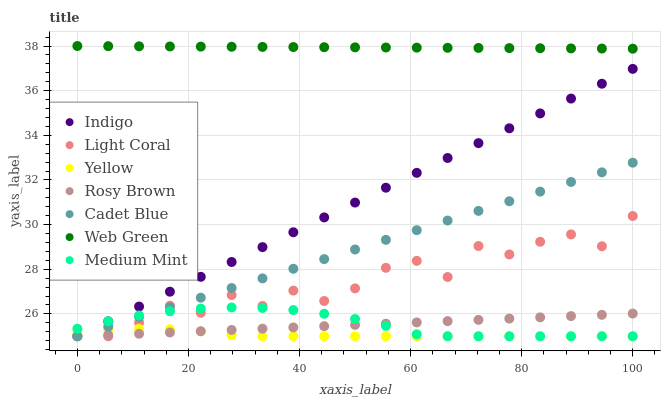Does Yellow have the minimum area under the curve?
Answer yes or no. Yes. Does Web Green have the maximum area under the curve?
Answer yes or no. Yes. Does Cadet Blue have the minimum area under the curve?
Answer yes or no. No. Does Cadet Blue have the maximum area under the curve?
Answer yes or no. No. Is Rosy Brown the smoothest?
Answer yes or no. Yes. Is Light Coral the roughest?
Answer yes or no. Yes. Is Cadet Blue the smoothest?
Answer yes or no. No. Is Cadet Blue the roughest?
Answer yes or no. No. Does Medium Mint have the lowest value?
Answer yes or no. Yes. Does Web Green have the lowest value?
Answer yes or no. No. Does Web Green have the highest value?
Answer yes or no. Yes. Does Cadet Blue have the highest value?
Answer yes or no. No. Is Rosy Brown less than Web Green?
Answer yes or no. Yes. Is Web Green greater than Medium Mint?
Answer yes or no. Yes. Does Cadet Blue intersect Medium Mint?
Answer yes or no. Yes. Is Cadet Blue less than Medium Mint?
Answer yes or no. No. Is Cadet Blue greater than Medium Mint?
Answer yes or no. No. Does Rosy Brown intersect Web Green?
Answer yes or no. No. 